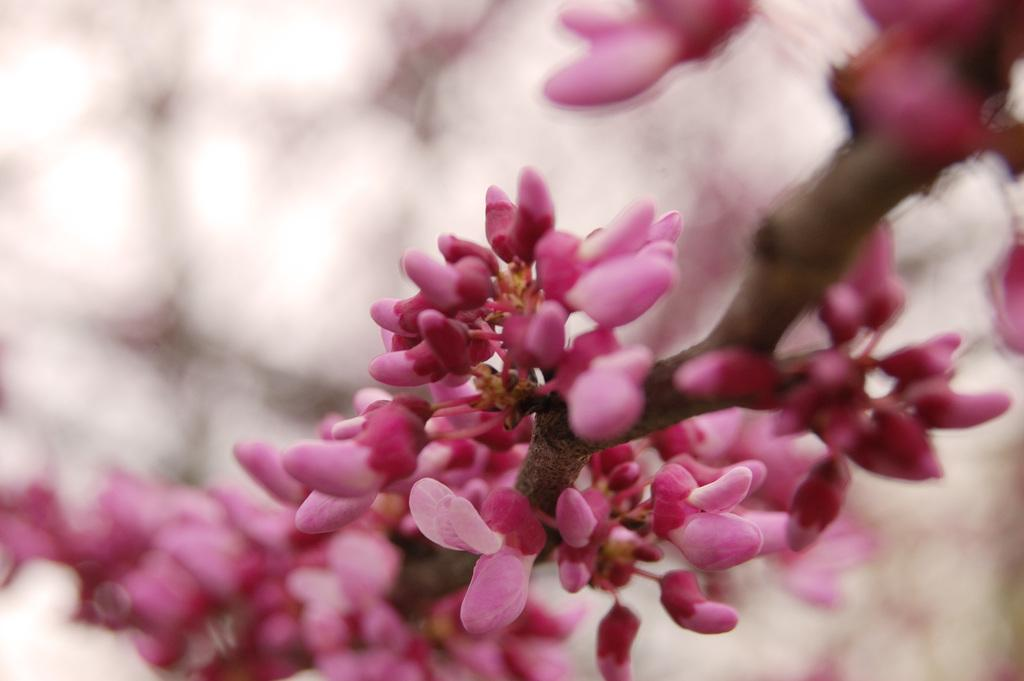What types of plants are in the image? There are flowers and buds in the image. What color are the flowers and buds? The flowers and buds are pink in color. How are the flowers and buds arranged in the image? The flowers and buds are on a stem. What can be observed about the background of the image? The background of the image is blurred. What type of pest can be seen crawling on the sponge in the image? There is no sponge or pest present in the image; it features flowers and buds on a stem with a blurred background. 